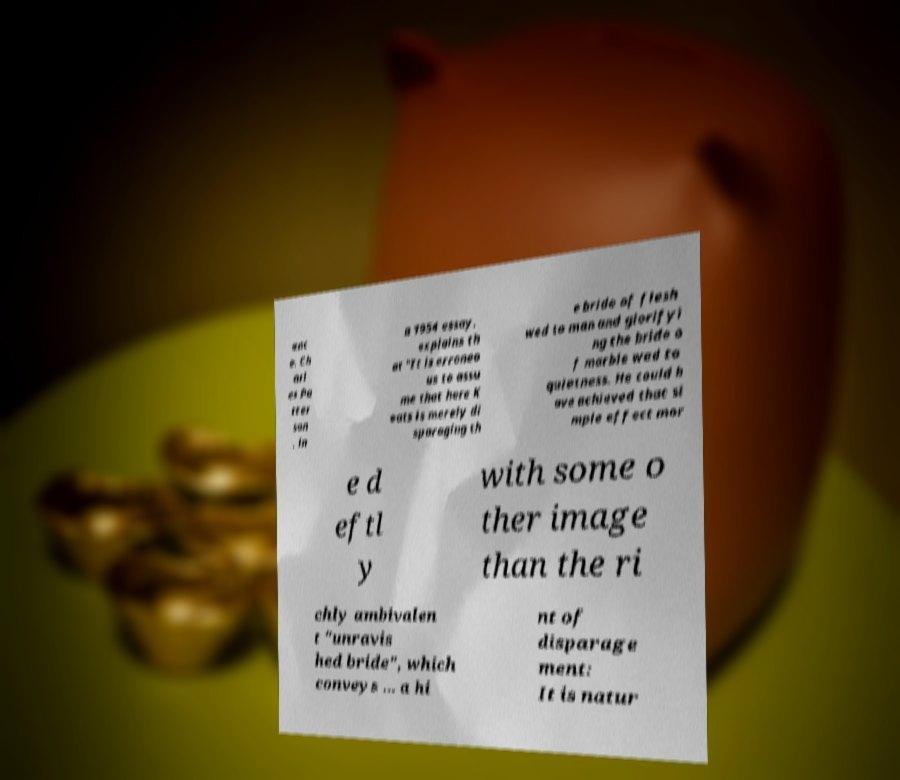Please read and relay the text visible in this image. What does it say? enc e. Ch arl es Pa tter son , in a 1954 essay, explains th at "It is erroneo us to assu me that here K eats is merely di sparaging th e bride of flesh wed to man and glorifyi ng the bride o f marble wed to quietness. He could h ave achieved that si mple effect mor e d eftl y with some o ther image than the ri chly ambivalen t "unravis hed bride", which conveys ... a hi nt of disparage ment: It is natur 